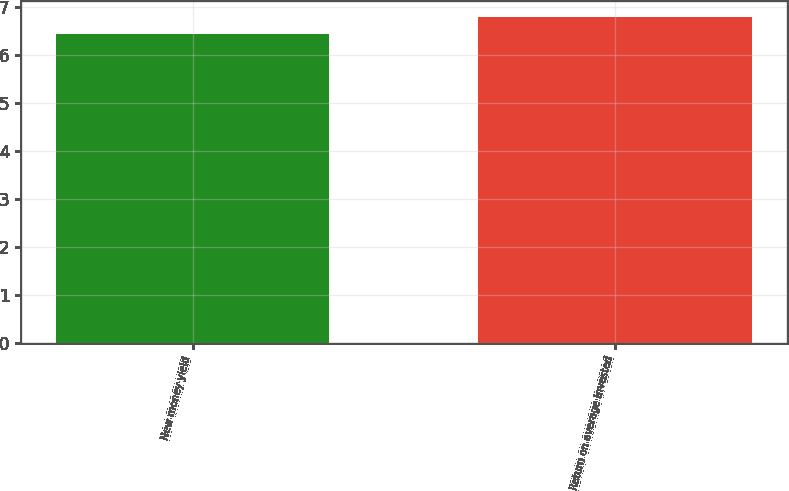Convert chart. <chart><loc_0><loc_0><loc_500><loc_500><bar_chart><fcel>New money yield<fcel>Return on average invested<nl><fcel>6.44<fcel>6.79<nl></chart> 